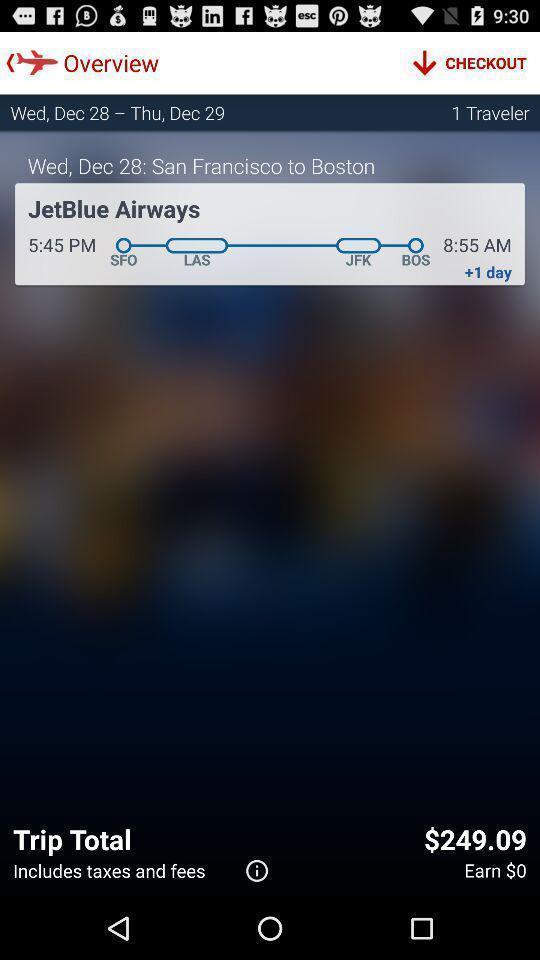Provide a textual representation of this image. Screen shows trip details page in travel application. 